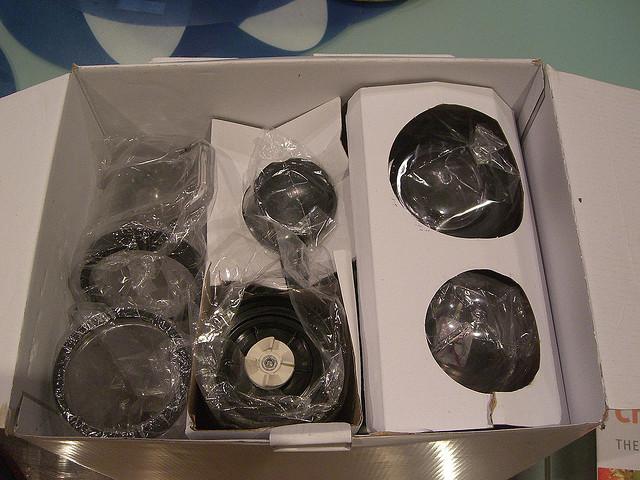What could this contraption be used for?
Short answer required. Blending. What color is the box?
Give a very brief answer. White. Is there any blue?
Short answer required. Yes. 